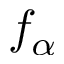<formula> <loc_0><loc_0><loc_500><loc_500>f _ { \alpha }</formula> 